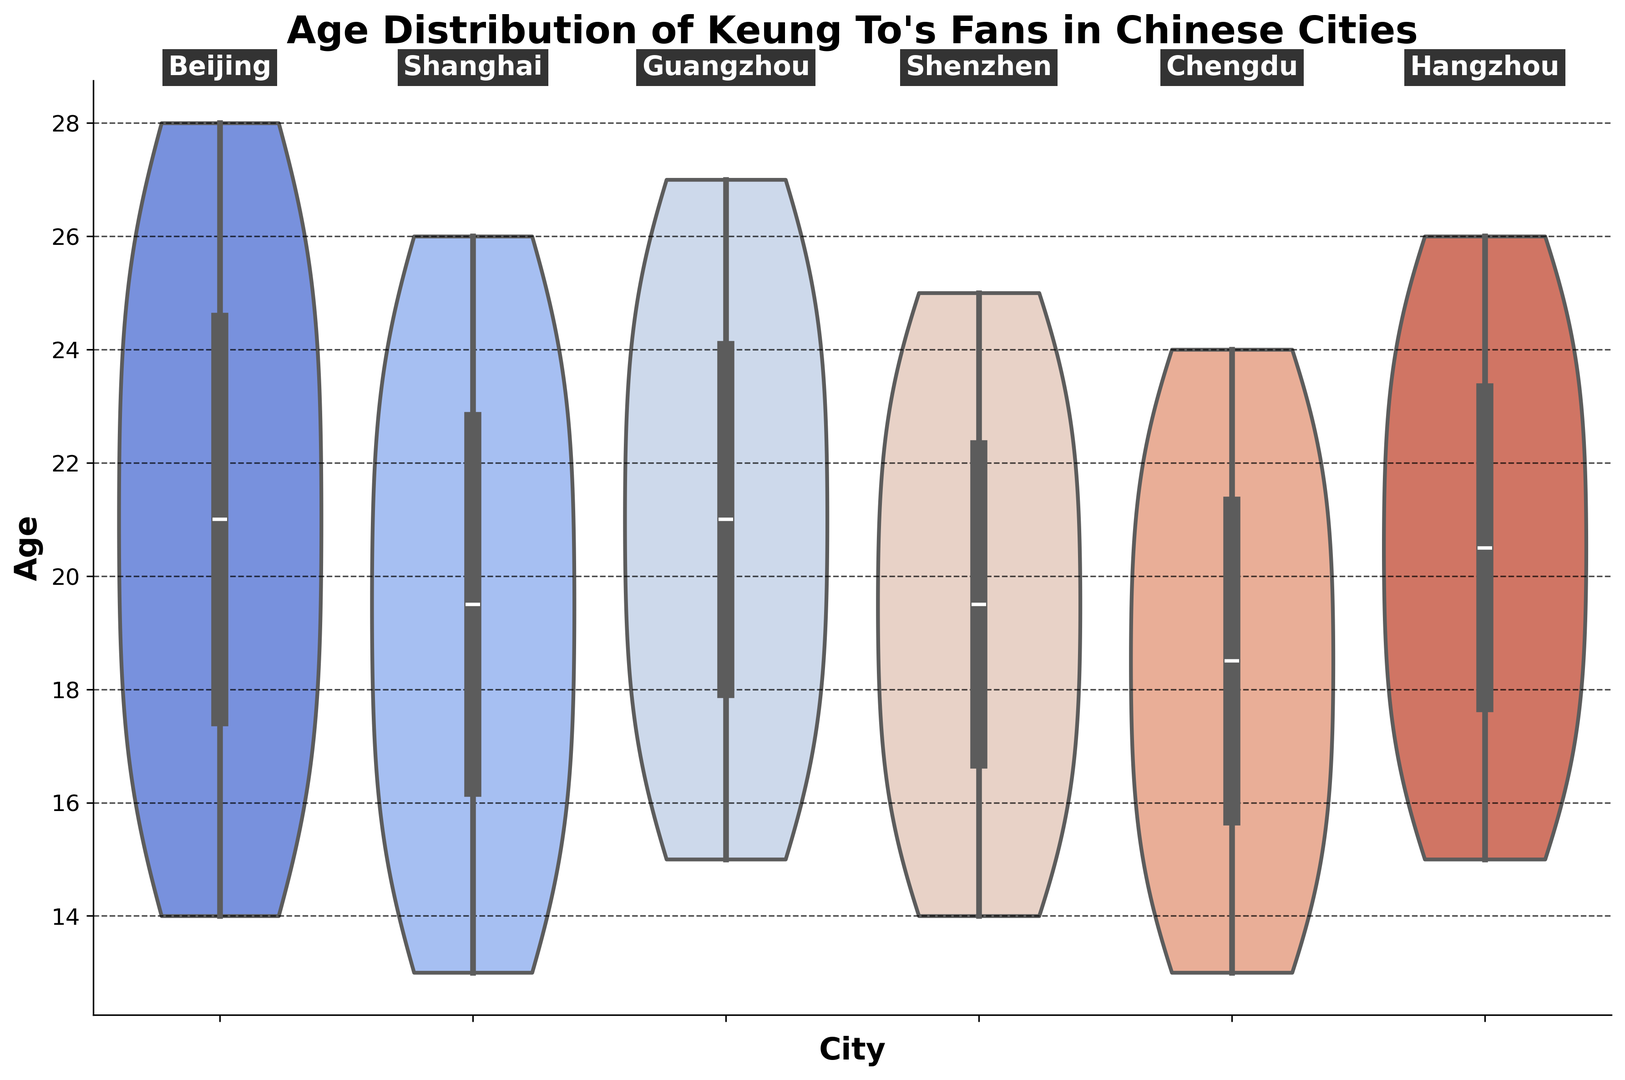Which city has the smallest age range of Keung To's fans? The smallest age range can be observed by looking at the height of the city violins. Chengdu appears to have the smallest vertical length, indicating the smallest age range.
Answer: Chengdu Which city has the highest density of teenage fans (ages 13-19)? The density can be judged by the width of the violin plot in the age range 13-19. Shanghai and Shenzhen show significant widths in this band, but Shanghai appears a bit wider.
Answer: Shanghai What's the overall median age of Keung To's fans across all cities? To find the overall median, we should identify the central line (representing the median) in each city's violin plot and then estimate an overall median from these values. Most cities have their median line close to 20.
Answer: ~20 Which city shows a wider fan age distribution, Beijing or Hangzhou? We compare the spread of the violin plots for Beijing and Hangzhou. Hangzhou appears to have a wider plot, indicating a broader distribution of ages.
Answer: Hangzhou Are there any cities where the age distribution is skewed towards younger fans? Skewness can be observed if one end of the violin plot is noticeably thicker or if the distribution is shifted toward younger ages. Chengdu shows a thick bottom portion, indicating a skew towards younger fans.
Answer: Chengdu has a skew towards younger fans In which city is the middle 50% of fans' ages most spread out? The spread of the middle 50% can be observed by the box inside the violin plots. The wider the box, the more spread out the middle 50%. Hangzhou appears to have a very spread-out middle 50%.
Answer: Hangzhou Which city has the age distribution centered around 20 years old? The center of the age distribution can be found by looking at where the widest part of the violin plot is around 20 years. Cities like Beijing, Guangzhou, and Hangzhou have distributions centered around 20.
Answer: Beijing, Guangzhou, Hangzhou How do the age distributions of Guangzhou and Shenzhen compare? We compare the spread and shape of the violin plots for Guangzhou and Shenzhen. Both have similar spreads but Guangzhou's distribution is more elongated, indicating a wider age range.
Answer: Both cities have similar spreads with Guangzhou having a wider range For which city do we see a high density of fans in their early 20s? A high density in early 20s can be seen from the thickness of the violin plot around ages 20-24. Beijing and Hangzhou show significant widths in this age range.
Answer: Beijing, Hangzhou What's the general age trend of Keung To's fans in mainland China? The general trend can be identified by looking at all the violin plots and finding where most of the densities and medians lie. Most violin plots show fans in their teens to mid-20s, with medians close to 20.
Answer: Teens to mid-20s, median around 20 